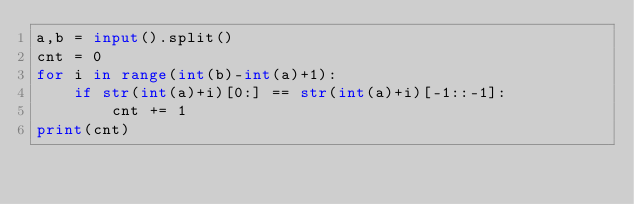Convert code to text. <code><loc_0><loc_0><loc_500><loc_500><_Python_>a,b = input().split()
cnt = 0
for i in range(int(b)-int(a)+1):
    if str(int(a)+i)[0:] == str(int(a)+i)[-1::-1]:
        cnt += 1
print(cnt)</code> 